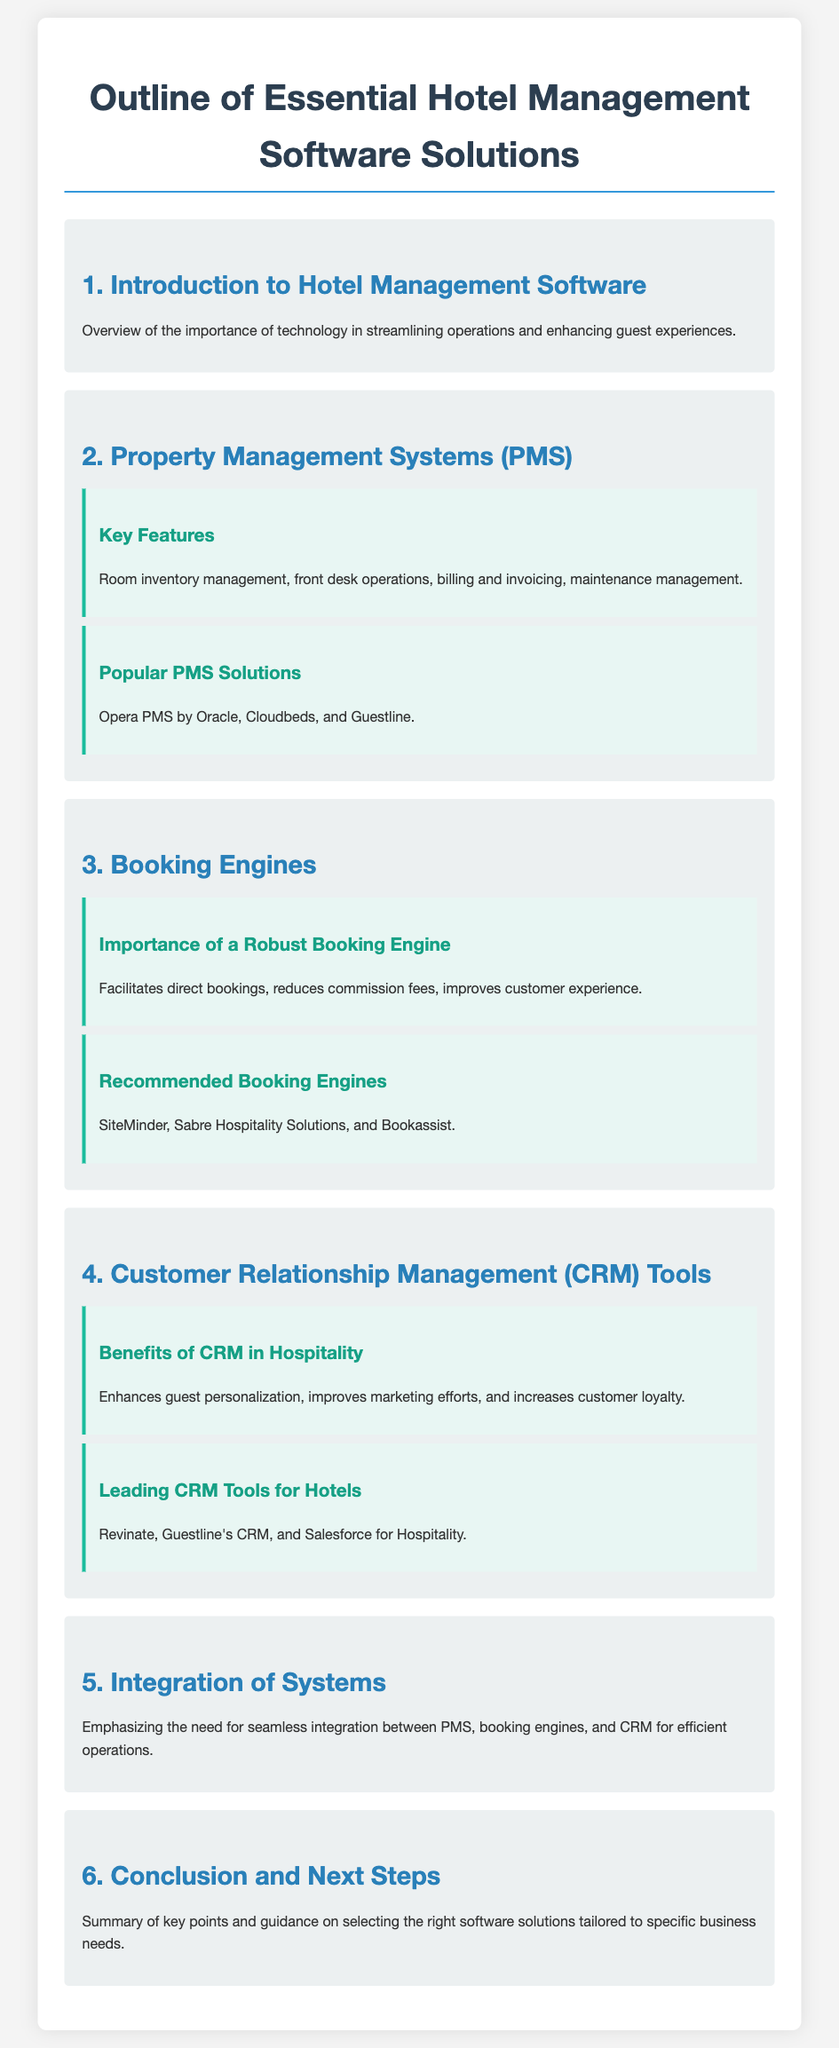What is the main focus of hotel management software? The document states that hotel management software is important for streamlining operations and enhancing guest experiences.
Answer: Streamlining operations and enhancing guest experiences What management feature involves billing and invoicing? The section on Property Management Systems mentions billing and invoicing as a key feature.
Answer: Billing and invoicing Which PMS solution is provided by Oracle? The document lists Opera PMS as a popular PMS solution provided by Oracle.
Answer: Opera PMS What does a robust booking engine facilitate? The text under "Importance of a Robust Booking Engine" mentions that it facilitates direct bookings.
Answer: Direct bookings Name a leading CRM tool mentioned in the document. The document states Revinate as one of the leading CRM tools for hotels.
Answer: Revinate What is emphasized regarding the integration of systems? The conclusion suggests the need for seamless integration between PMS, booking engines, and CRM for efficient operations.
Answer: Seamless integration How many key sections are outlined in the document? The document lists a total of six key sections from introduction to conclusion.
Answer: Six What is one benefit of CRM tools in hospitality? The document states that one benefit of CRM is enhancing guest personalization.
Answer: Enhancing guest personalization Which booking engine is recommended in the document? The document lists SiteMinder as one of the recommended booking engines.
Answer: SiteMinder 